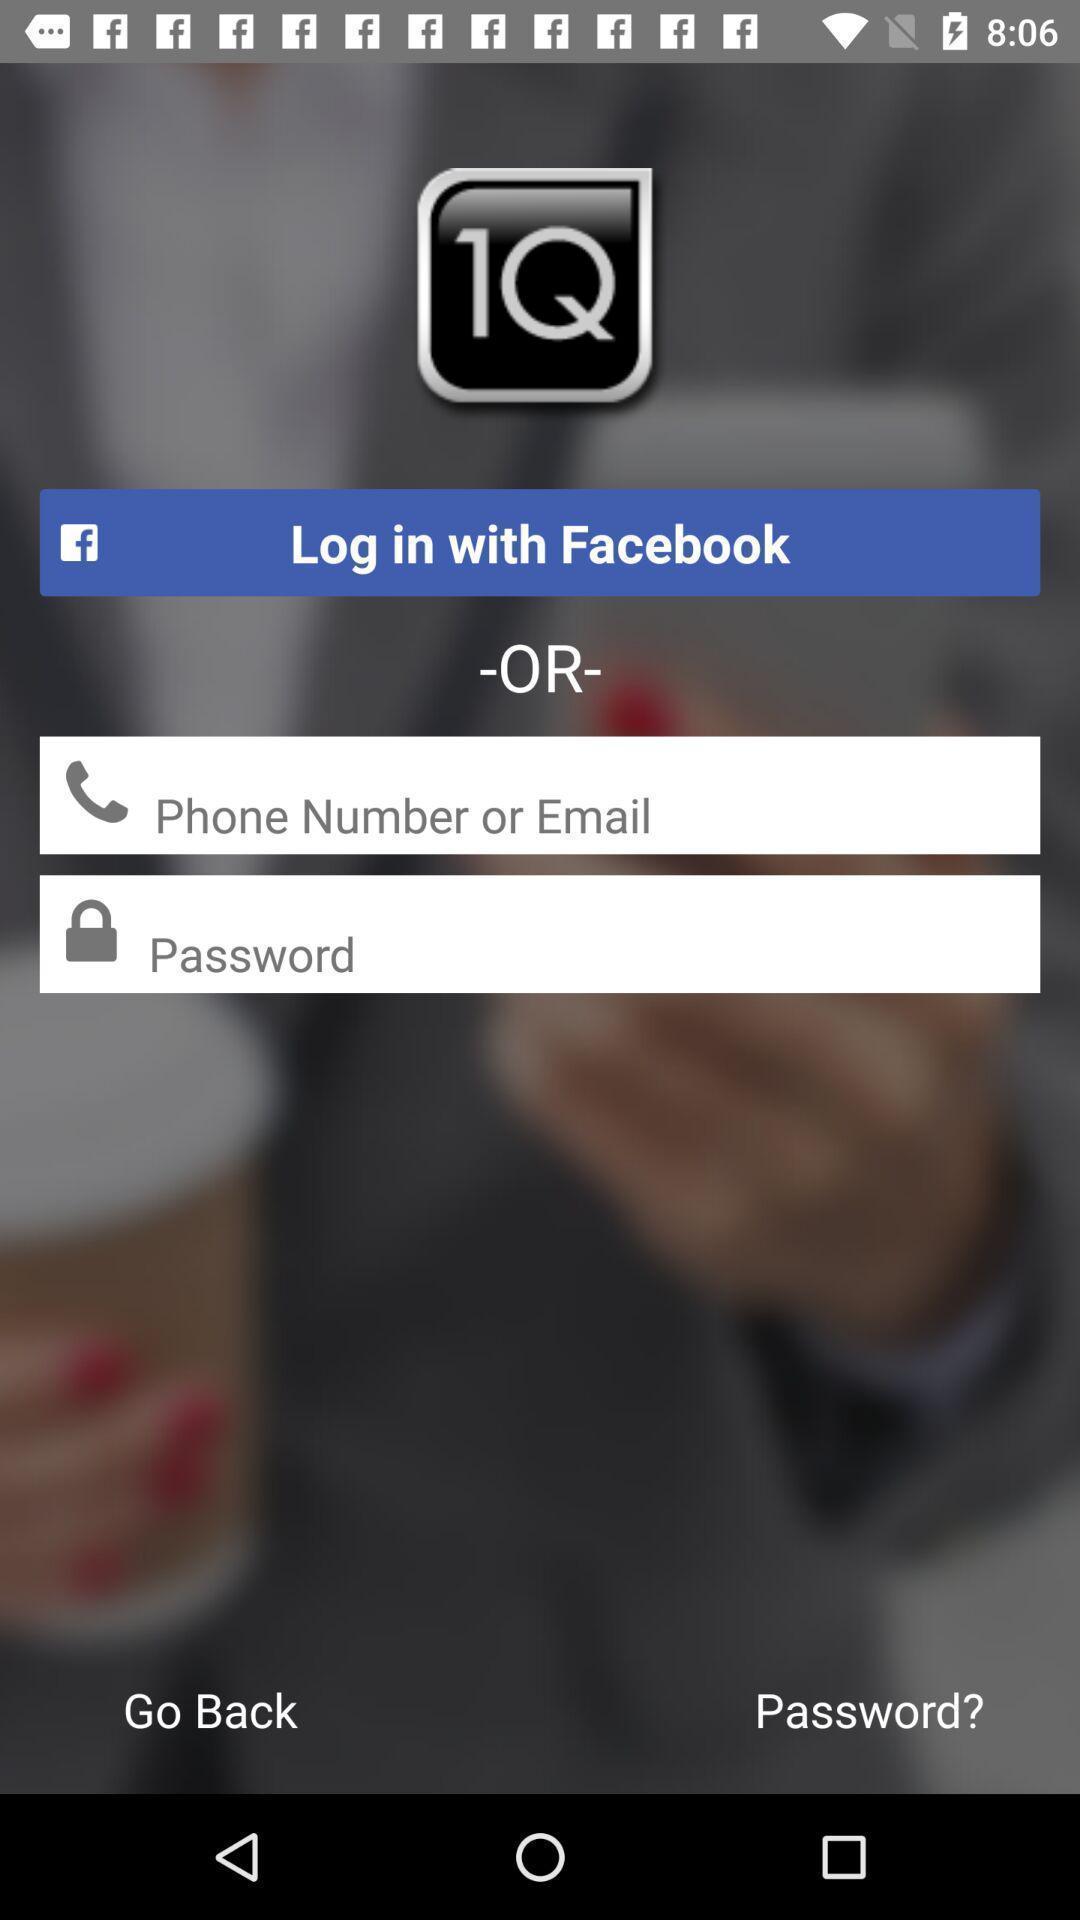What is the overall content of this screenshot? Login page. 